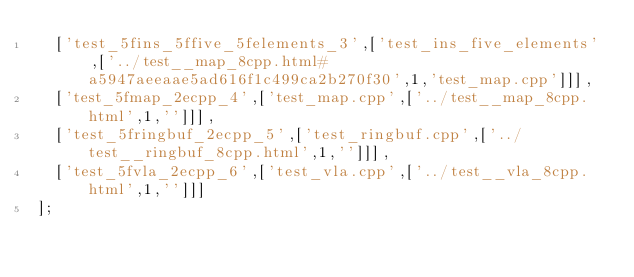<code> <loc_0><loc_0><loc_500><loc_500><_JavaScript_>  ['test_5fins_5ffive_5felements_3',['test_ins_five_elements',['../test__map_8cpp.html#a5947aeeaae5ad616f1c499ca2b270f30',1,'test_map.cpp']]],
  ['test_5fmap_2ecpp_4',['test_map.cpp',['../test__map_8cpp.html',1,'']]],
  ['test_5fringbuf_2ecpp_5',['test_ringbuf.cpp',['../test__ringbuf_8cpp.html',1,'']]],
  ['test_5fvla_2ecpp_6',['test_vla.cpp',['../test__vla_8cpp.html',1,'']]]
];
</code> 